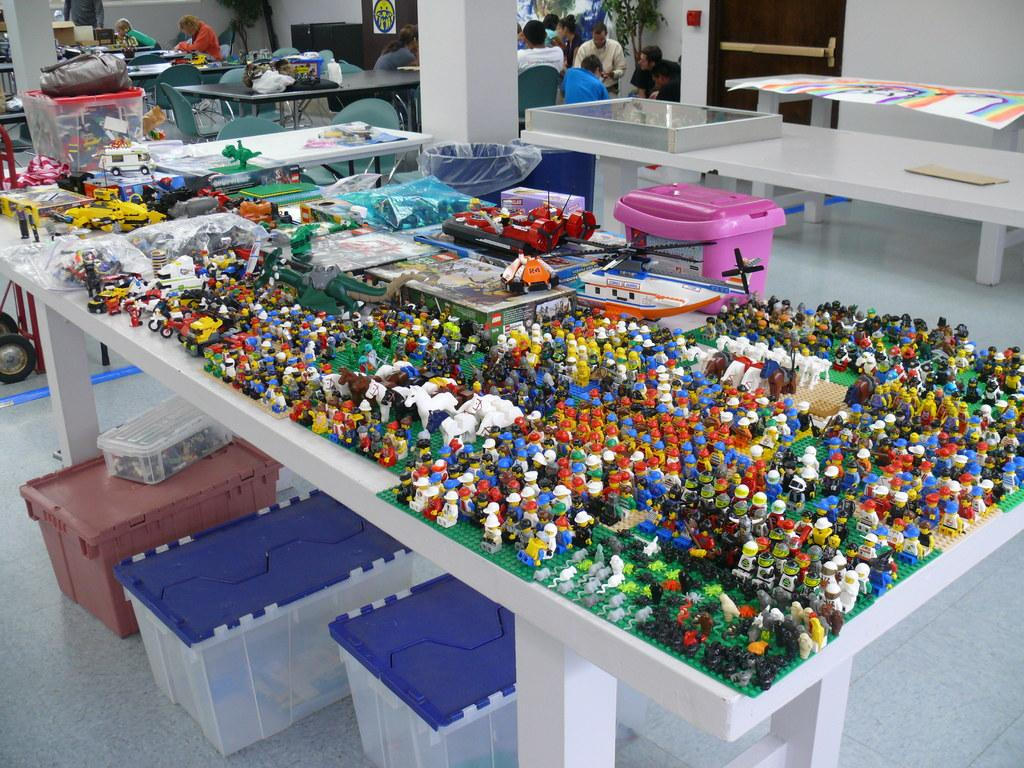What type of toys are on the table in the image? There are lego toys on a table in the image. What can be seen on the floor near the table? There are three boxes on the floor. What is happening in the background of the image? There are many tables with people sitting around them in the background. What type of punishment is being given to the lego toys in the image? There is no punishment being given to the lego toys in the image; they are simply sitting on the table. What kind of brick is being used to build the lego structure in the image? There is no brick visible in the image, only lego toys. 